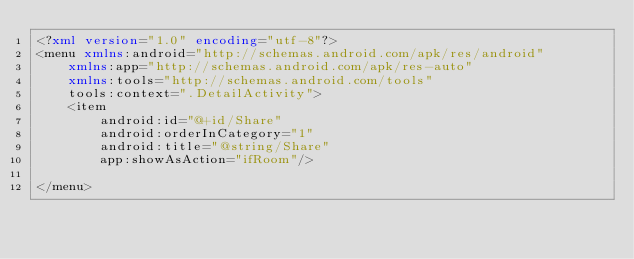Convert code to text. <code><loc_0><loc_0><loc_500><loc_500><_XML_><?xml version="1.0" encoding="utf-8"?>
<menu xmlns:android="http://schemas.android.com/apk/res/android"
    xmlns:app="http://schemas.android.com/apk/res-auto"
    xmlns:tools="http://schemas.android.com/tools"
    tools:context=".DetailActivity">
    <item
        android:id="@+id/Share"
        android:orderInCategory="1"
        android:title="@string/Share"
        app:showAsAction="ifRoom"/>

</menu></code> 